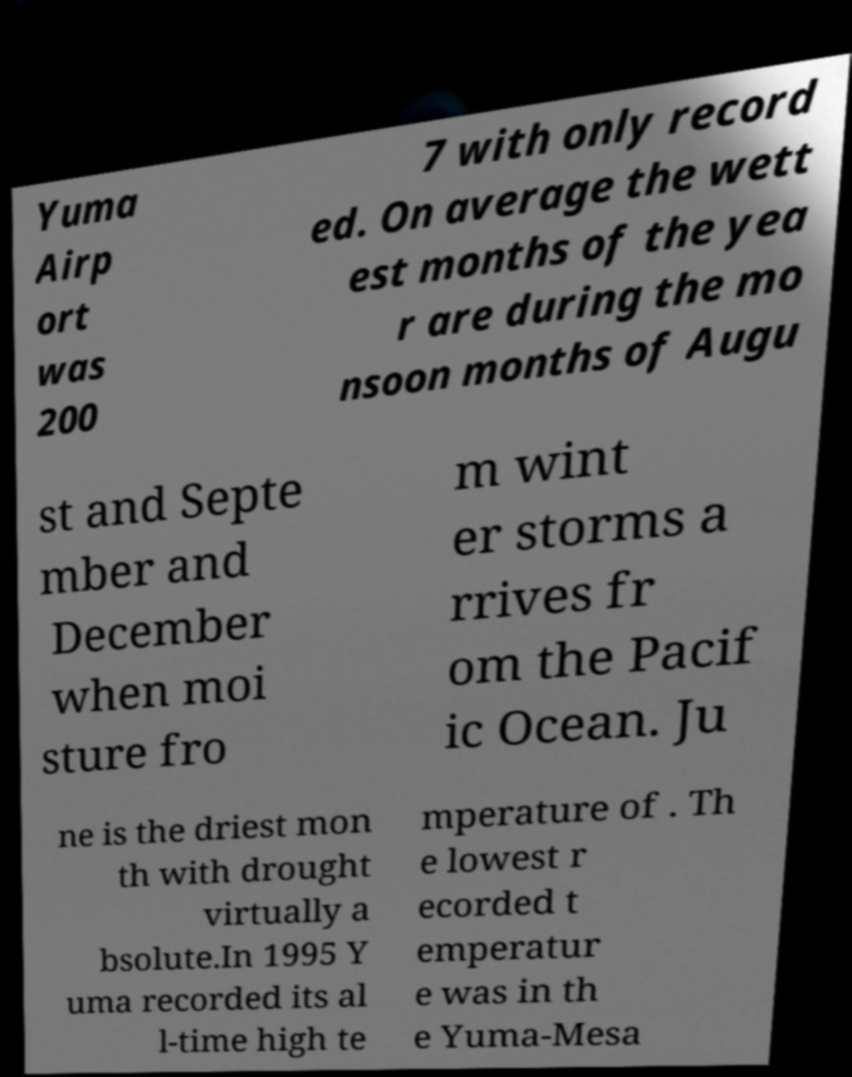There's text embedded in this image that I need extracted. Can you transcribe it verbatim? Yuma Airp ort was 200 7 with only record ed. On average the wett est months of the yea r are during the mo nsoon months of Augu st and Septe mber and December when moi sture fro m wint er storms a rrives fr om the Pacif ic Ocean. Ju ne is the driest mon th with drought virtually a bsolute.In 1995 Y uma recorded its al l-time high te mperature of . Th e lowest r ecorded t emperatur e was in th e Yuma-Mesa 